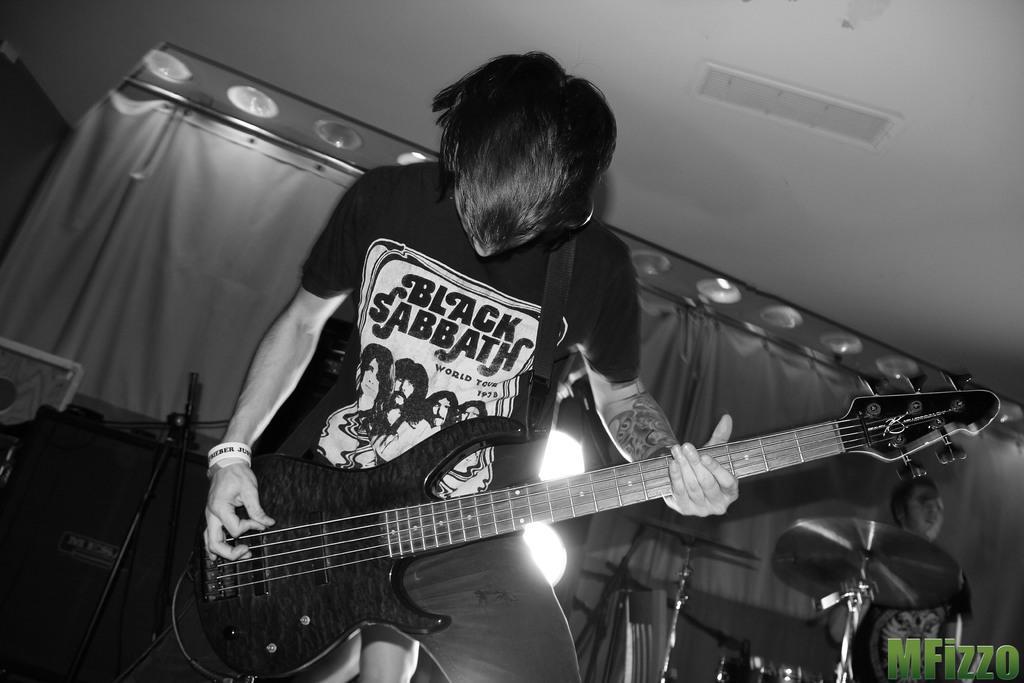Please provide a concise description of this image. A man is standing and playing the guitar with his hands. 